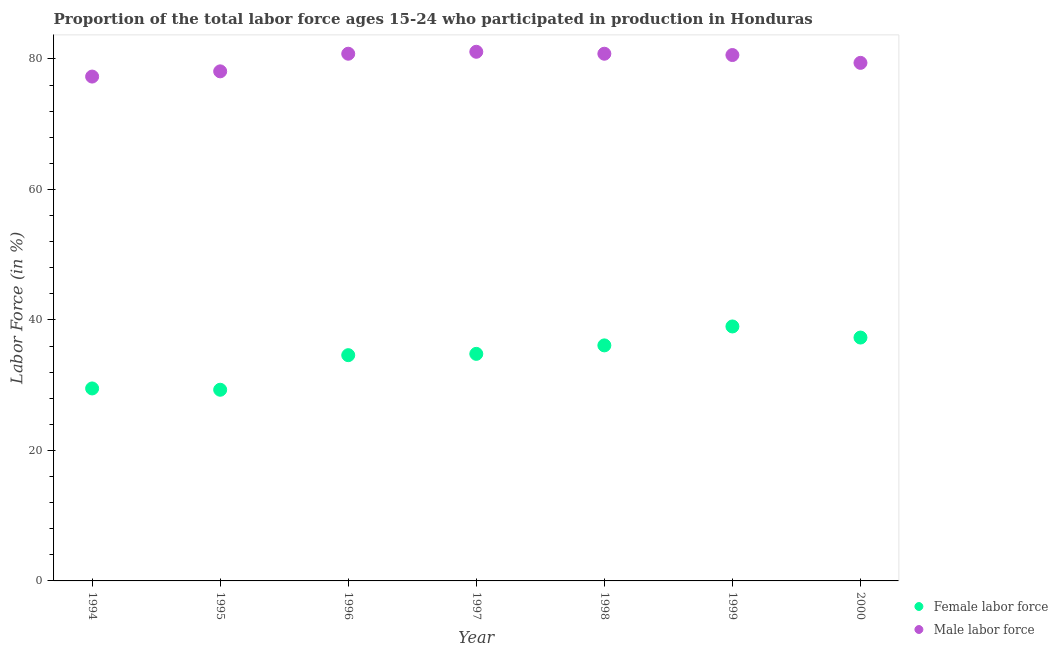Is the number of dotlines equal to the number of legend labels?
Offer a very short reply. Yes. What is the percentage of male labour force in 1995?
Your answer should be compact. 78.1. Across all years, what is the maximum percentage of female labor force?
Give a very brief answer. 39. Across all years, what is the minimum percentage of female labor force?
Your response must be concise. 29.3. What is the total percentage of male labour force in the graph?
Offer a terse response. 558.1. What is the difference between the percentage of female labor force in 1997 and that in 2000?
Make the answer very short. -2.5. What is the difference between the percentage of female labor force in 1999 and the percentage of male labour force in 1998?
Provide a short and direct response. -41.8. What is the average percentage of male labour force per year?
Keep it short and to the point. 79.73. In the year 1994, what is the difference between the percentage of female labor force and percentage of male labour force?
Offer a very short reply. -47.8. In how many years, is the percentage of female labor force greater than 48 %?
Offer a terse response. 0. What is the ratio of the percentage of male labour force in 1994 to that in 1995?
Keep it short and to the point. 0.99. What is the difference between the highest and the second highest percentage of female labor force?
Make the answer very short. 1.7. What is the difference between the highest and the lowest percentage of male labour force?
Provide a short and direct response. 3.8. Is the sum of the percentage of male labour force in 1997 and 1999 greater than the maximum percentage of female labor force across all years?
Ensure brevity in your answer.  Yes. Does the percentage of male labour force monotonically increase over the years?
Ensure brevity in your answer.  No. Is the percentage of female labor force strictly greater than the percentage of male labour force over the years?
Provide a succinct answer. No. Is the percentage of male labour force strictly less than the percentage of female labor force over the years?
Your answer should be compact. No. What is the difference between two consecutive major ticks on the Y-axis?
Ensure brevity in your answer.  20. Does the graph contain grids?
Offer a terse response. No. How are the legend labels stacked?
Your response must be concise. Vertical. What is the title of the graph?
Your response must be concise. Proportion of the total labor force ages 15-24 who participated in production in Honduras. What is the Labor Force (in %) in Female labor force in 1994?
Give a very brief answer. 29.5. What is the Labor Force (in %) in Male labor force in 1994?
Make the answer very short. 77.3. What is the Labor Force (in %) in Female labor force in 1995?
Offer a terse response. 29.3. What is the Labor Force (in %) in Male labor force in 1995?
Your response must be concise. 78.1. What is the Labor Force (in %) of Female labor force in 1996?
Your response must be concise. 34.6. What is the Labor Force (in %) in Male labor force in 1996?
Provide a succinct answer. 80.8. What is the Labor Force (in %) of Female labor force in 1997?
Ensure brevity in your answer.  34.8. What is the Labor Force (in %) of Male labor force in 1997?
Your response must be concise. 81.1. What is the Labor Force (in %) in Female labor force in 1998?
Provide a short and direct response. 36.1. What is the Labor Force (in %) in Male labor force in 1998?
Keep it short and to the point. 80.8. What is the Labor Force (in %) of Male labor force in 1999?
Give a very brief answer. 80.6. What is the Labor Force (in %) of Female labor force in 2000?
Offer a very short reply. 37.3. What is the Labor Force (in %) of Male labor force in 2000?
Your answer should be compact. 79.4. Across all years, what is the maximum Labor Force (in %) in Female labor force?
Offer a terse response. 39. Across all years, what is the maximum Labor Force (in %) in Male labor force?
Give a very brief answer. 81.1. Across all years, what is the minimum Labor Force (in %) of Female labor force?
Offer a very short reply. 29.3. Across all years, what is the minimum Labor Force (in %) in Male labor force?
Ensure brevity in your answer.  77.3. What is the total Labor Force (in %) of Female labor force in the graph?
Give a very brief answer. 240.6. What is the total Labor Force (in %) of Male labor force in the graph?
Keep it short and to the point. 558.1. What is the difference between the Labor Force (in %) of Female labor force in 1994 and that in 1995?
Offer a terse response. 0.2. What is the difference between the Labor Force (in %) of Male labor force in 1994 and that in 1995?
Provide a succinct answer. -0.8. What is the difference between the Labor Force (in %) in Male labor force in 1994 and that in 1996?
Your response must be concise. -3.5. What is the difference between the Labor Force (in %) of Female labor force in 1994 and that in 1997?
Your answer should be very brief. -5.3. What is the difference between the Labor Force (in %) of Male labor force in 1994 and that in 1997?
Provide a succinct answer. -3.8. What is the difference between the Labor Force (in %) of Female labor force in 1994 and that in 1998?
Your answer should be very brief. -6.6. What is the difference between the Labor Force (in %) of Male labor force in 1994 and that in 1999?
Your answer should be compact. -3.3. What is the difference between the Labor Force (in %) in Male labor force in 1995 and that in 1996?
Offer a very short reply. -2.7. What is the difference between the Labor Force (in %) of Female labor force in 1995 and that in 1997?
Offer a very short reply. -5.5. What is the difference between the Labor Force (in %) of Male labor force in 1995 and that in 1997?
Your response must be concise. -3. What is the difference between the Labor Force (in %) of Female labor force in 1995 and that in 2000?
Make the answer very short. -8. What is the difference between the Labor Force (in %) of Male labor force in 1995 and that in 2000?
Your response must be concise. -1.3. What is the difference between the Labor Force (in %) in Female labor force in 1996 and that in 1997?
Your answer should be very brief. -0.2. What is the difference between the Labor Force (in %) of Male labor force in 1996 and that in 1997?
Ensure brevity in your answer.  -0.3. What is the difference between the Labor Force (in %) in Male labor force in 1996 and that in 1998?
Make the answer very short. 0. What is the difference between the Labor Force (in %) in Male labor force in 1996 and that in 1999?
Offer a terse response. 0.2. What is the difference between the Labor Force (in %) of Male labor force in 1996 and that in 2000?
Ensure brevity in your answer.  1.4. What is the difference between the Labor Force (in %) of Male labor force in 1997 and that in 1998?
Keep it short and to the point. 0.3. What is the difference between the Labor Force (in %) of Female labor force in 1997 and that in 2000?
Your answer should be very brief. -2.5. What is the difference between the Labor Force (in %) in Male labor force in 1997 and that in 2000?
Provide a succinct answer. 1.7. What is the difference between the Labor Force (in %) in Female labor force in 1998 and that in 1999?
Provide a succinct answer. -2.9. What is the difference between the Labor Force (in %) in Male labor force in 1998 and that in 1999?
Provide a short and direct response. 0.2. What is the difference between the Labor Force (in %) of Female labor force in 1998 and that in 2000?
Provide a short and direct response. -1.2. What is the difference between the Labor Force (in %) in Male labor force in 1998 and that in 2000?
Ensure brevity in your answer.  1.4. What is the difference between the Labor Force (in %) of Female labor force in 1999 and that in 2000?
Provide a succinct answer. 1.7. What is the difference between the Labor Force (in %) in Male labor force in 1999 and that in 2000?
Give a very brief answer. 1.2. What is the difference between the Labor Force (in %) of Female labor force in 1994 and the Labor Force (in %) of Male labor force in 1995?
Your answer should be very brief. -48.6. What is the difference between the Labor Force (in %) of Female labor force in 1994 and the Labor Force (in %) of Male labor force in 1996?
Give a very brief answer. -51.3. What is the difference between the Labor Force (in %) in Female labor force in 1994 and the Labor Force (in %) in Male labor force in 1997?
Your answer should be compact. -51.6. What is the difference between the Labor Force (in %) in Female labor force in 1994 and the Labor Force (in %) in Male labor force in 1998?
Your answer should be compact. -51.3. What is the difference between the Labor Force (in %) in Female labor force in 1994 and the Labor Force (in %) in Male labor force in 1999?
Your answer should be compact. -51.1. What is the difference between the Labor Force (in %) in Female labor force in 1994 and the Labor Force (in %) in Male labor force in 2000?
Your answer should be compact. -49.9. What is the difference between the Labor Force (in %) in Female labor force in 1995 and the Labor Force (in %) in Male labor force in 1996?
Your answer should be compact. -51.5. What is the difference between the Labor Force (in %) of Female labor force in 1995 and the Labor Force (in %) of Male labor force in 1997?
Provide a short and direct response. -51.8. What is the difference between the Labor Force (in %) of Female labor force in 1995 and the Labor Force (in %) of Male labor force in 1998?
Offer a very short reply. -51.5. What is the difference between the Labor Force (in %) in Female labor force in 1995 and the Labor Force (in %) in Male labor force in 1999?
Your answer should be compact. -51.3. What is the difference between the Labor Force (in %) of Female labor force in 1995 and the Labor Force (in %) of Male labor force in 2000?
Ensure brevity in your answer.  -50.1. What is the difference between the Labor Force (in %) in Female labor force in 1996 and the Labor Force (in %) in Male labor force in 1997?
Keep it short and to the point. -46.5. What is the difference between the Labor Force (in %) in Female labor force in 1996 and the Labor Force (in %) in Male labor force in 1998?
Your answer should be compact. -46.2. What is the difference between the Labor Force (in %) in Female labor force in 1996 and the Labor Force (in %) in Male labor force in 1999?
Keep it short and to the point. -46. What is the difference between the Labor Force (in %) in Female labor force in 1996 and the Labor Force (in %) in Male labor force in 2000?
Offer a very short reply. -44.8. What is the difference between the Labor Force (in %) of Female labor force in 1997 and the Labor Force (in %) of Male labor force in 1998?
Your response must be concise. -46. What is the difference between the Labor Force (in %) of Female labor force in 1997 and the Labor Force (in %) of Male labor force in 1999?
Your answer should be compact. -45.8. What is the difference between the Labor Force (in %) in Female labor force in 1997 and the Labor Force (in %) in Male labor force in 2000?
Keep it short and to the point. -44.6. What is the difference between the Labor Force (in %) in Female labor force in 1998 and the Labor Force (in %) in Male labor force in 1999?
Make the answer very short. -44.5. What is the difference between the Labor Force (in %) in Female labor force in 1998 and the Labor Force (in %) in Male labor force in 2000?
Your response must be concise. -43.3. What is the difference between the Labor Force (in %) of Female labor force in 1999 and the Labor Force (in %) of Male labor force in 2000?
Provide a short and direct response. -40.4. What is the average Labor Force (in %) of Female labor force per year?
Offer a very short reply. 34.37. What is the average Labor Force (in %) of Male labor force per year?
Offer a very short reply. 79.73. In the year 1994, what is the difference between the Labor Force (in %) in Female labor force and Labor Force (in %) in Male labor force?
Ensure brevity in your answer.  -47.8. In the year 1995, what is the difference between the Labor Force (in %) of Female labor force and Labor Force (in %) of Male labor force?
Ensure brevity in your answer.  -48.8. In the year 1996, what is the difference between the Labor Force (in %) of Female labor force and Labor Force (in %) of Male labor force?
Keep it short and to the point. -46.2. In the year 1997, what is the difference between the Labor Force (in %) in Female labor force and Labor Force (in %) in Male labor force?
Make the answer very short. -46.3. In the year 1998, what is the difference between the Labor Force (in %) of Female labor force and Labor Force (in %) of Male labor force?
Your answer should be very brief. -44.7. In the year 1999, what is the difference between the Labor Force (in %) in Female labor force and Labor Force (in %) in Male labor force?
Offer a very short reply. -41.6. In the year 2000, what is the difference between the Labor Force (in %) of Female labor force and Labor Force (in %) of Male labor force?
Your answer should be very brief. -42.1. What is the ratio of the Labor Force (in %) in Female labor force in 1994 to that in 1995?
Ensure brevity in your answer.  1.01. What is the ratio of the Labor Force (in %) of Male labor force in 1994 to that in 1995?
Provide a succinct answer. 0.99. What is the ratio of the Labor Force (in %) of Female labor force in 1994 to that in 1996?
Give a very brief answer. 0.85. What is the ratio of the Labor Force (in %) of Male labor force in 1994 to that in 1996?
Make the answer very short. 0.96. What is the ratio of the Labor Force (in %) in Female labor force in 1994 to that in 1997?
Your response must be concise. 0.85. What is the ratio of the Labor Force (in %) of Male labor force in 1994 to that in 1997?
Your response must be concise. 0.95. What is the ratio of the Labor Force (in %) of Female labor force in 1994 to that in 1998?
Your answer should be compact. 0.82. What is the ratio of the Labor Force (in %) of Male labor force in 1994 to that in 1998?
Your response must be concise. 0.96. What is the ratio of the Labor Force (in %) of Female labor force in 1994 to that in 1999?
Your response must be concise. 0.76. What is the ratio of the Labor Force (in %) in Male labor force in 1994 to that in 1999?
Provide a short and direct response. 0.96. What is the ratio of the Labor Force (in %) of Female labor force in 1994 to that in 2000?
Keep it short and to the point. 0.79. What is the ratio of the Labor Force (in %) in Male labor force in 1994 to that in 2000?
Keep it short and to the point. 0.97. What is the ratio of the Labor Force (in %) of Female labor force in 1995 to that in 1996?
Make the answer very short. 0.85. What is the ratio of the Labor Force (in %) of Male labor force in 1995 to that in 1996?
Keep it short and to the point. 0.97. What is the ratio of the Labor Force (in %) of Female labor force in 1995 to that in 1997?
Ensure brevity in your answer.  0.84. What is the ratio of the Labor Force (in %) in Male labor force in 1995 to that in 1997?
Offer a terse response. 0.96. What is the ratio of the Labor Force (in %) of Female labor force in 1995 to that in 1998?
Give a very brief answer. 0.81. What is the ratio of the Labor Force (in %) of Male labor force in 1995 to that in 1998?
Give a very brief answer. 0.97. What is the ratio of the Labor Force (in %) of Female labor force in 1995 to that in 1999?
Your answer should be very brief. 0.75. What is the ratio of the Labor Force (in %) of Female labor force in 1995 to that in 2000?
Provide a short and direct response. 0.79. What is the ratio of the Labor Force (in %) of Male labor force in 1995 to that in 2000?
Give a very brief answer. 0.98. What is the ratio of the Labor Force (in %) in Female labor force in 1996 to that in 1997?
Provide a succinct answer. 0.99. What is the ratio of the Labor Force (in %) in Female labor force in 1996 to that in 1998?
Offer a very short reply. 0.96. What is the ratio of the Labor Force (in %) of Male labor force in 1996 to that in 1998?
Keep it short and to the point. 1. What is the ratio of the Labor Force (in %) of Female labor force in 1996 to that in 1999?
Provide a succinct answer. 0.89. What is the ratio of the Labor Force (in %) of Female labor force in 1996 to that in 2000?
Keep it short and to the point. 0.93. What is the ratio of the Labor Force (in %) in Male labor force in 1996 to that in 2000?
Provide a short and direct response. 1.02. What is the ratio of the Labor Force (in %) in Male labor force in 1997 to that in 1998?
Make the answer very short. 1. What is the ratio of the Labor Force (in %) in Female labor force in 1997 to that in 1999?
Make the answer very short. 0.89. What is the ratio of the Labor Force (in %) in Male labor force in 1997 to that in 1999?
Give a very brief answer. 1.01. What is the ratio of the Labor Force (in %) of Female labor force in 1997 to that in 2000?
Your response must be concise. 0.93. What is the ratio of the Labor Force (in %) in Male labor force in 1997 to that in 2000?
Ensure brevity in your answer.  1.02. What is the ratio of the Labor Force (in %) in Female labor force in 1998 to that in 1999?
Provide a succinct answer. 0.93. What is the ratio of the Labor Force (in %) in Female labor force in 1998 to that in 2000?
Ensure brevity in your answer.  0.97. What is the ratio of the Labor Force (in %) of Male labor force in 1998 to that in 2000?
Offer a terse response. 1.02. What is the ratio of the Labor Force (in %) of Female labor force in 1999 to that in 2000?
Your answer should be compact. 1.05. What is the ratio of the Labor Force (in %) in Male labor force in 1999 to that in 2000?
Provide a succinct answer. 1.02. What is the difference between the highest and the second highest Labor Force (in %) of Male labor force?
Your answer should be very brief. 0.3. What is the difference between the highest and the lowest Labor Force (in %) in Female labor force?
Offer a terse response. 9.7. What is the difference between the highest and the lowest Labor Force (in %) in Male labor force?
Give a very brief answer. 3.8. 